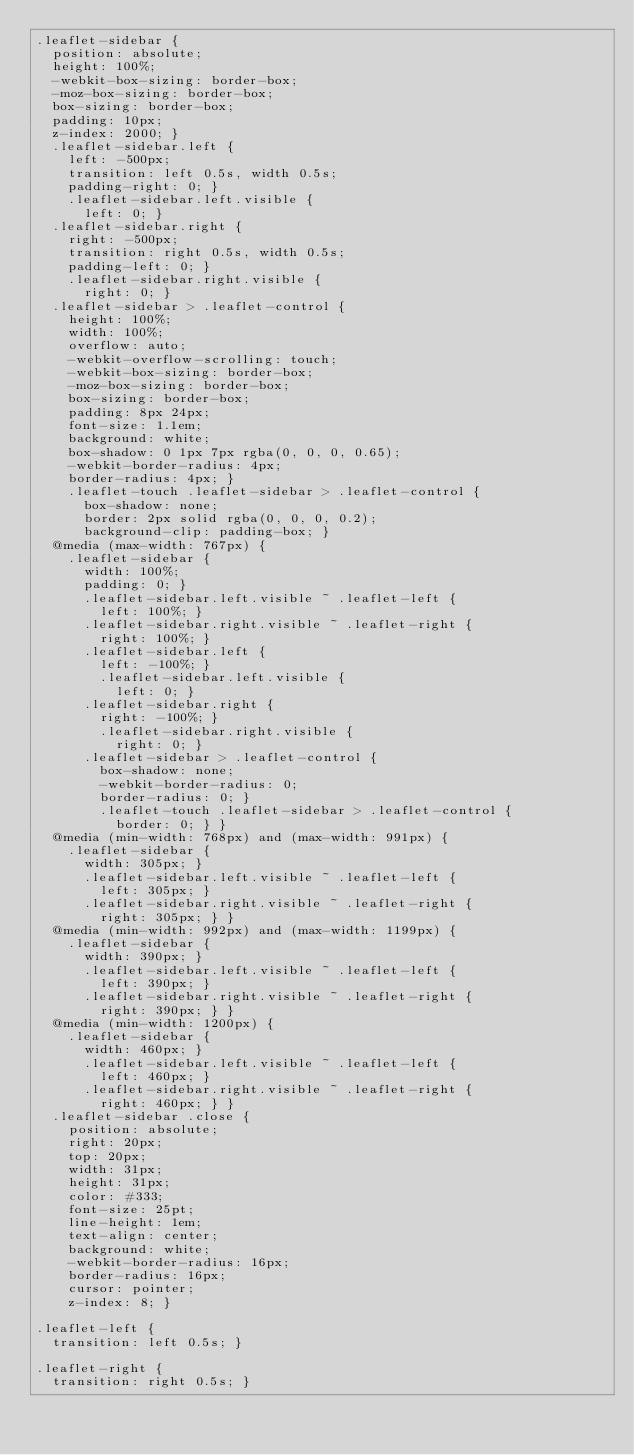Convert code to text. <code><loc_0><loc_0><loc_500><loc_500><_CSS_>.leaflet-sidebar {
  position: absolute;
  height: 100%;
  -webkit-box-sizing: border-box;
  -moz-box-sizing: border-box;
  box-sizing: border-box;
  padding: 10px;
  z-index: 2000; }
  .leaflet-sidebar.left {
    left: -500px;
    transition: left 0.5s, width 0.5s;
    padding-right: 0; }
    .leaflet-sidebar.left.visible {
      left: 0; }
  .leaflet-sidebar.right {
    right: -500px;
    transition: right 0.5s, width 0.5s;
    padding-left: 0; }
    .leaflet-sidebar.right.visible {
      right: 0; }
  .leaflet-sidebar > .leaflet-control {
    height: 100%;
    width: 100%;
    overflow: auto;
    -webkit-overflow-scrolling: touch;
    -webkit-box-sizing: border-box;
    -moz-box-sizing: border-box;
    box-sizing: border-box;
    padding: 8px 24px;
    font-size: 1.1em;
    background: white;
    box-shadow: 0 1px 7px rgba(0, 0, 0, 0.65);
    -webkit-border-radius: 4px;
    border-radius: 4px; }
    .leaflet-touch .leaflet-sidebar > .leaflet-control {
      box-shadow: none;
      border: 2px solid rgba(0, 0, 0, 0.2);
      background-clip: padding-box; }
  @media (max-width: 767px) {
    .leaflet-sidebar {
      width: 100%;
      padding: 0; }
      .leaflet-sidebar.left.visible ~ .leaflet-left {
        left: 100%; }
      .leaflet-sidebar.right.visible ~ .leaflet-right {
        right: 100%; }
      .leaflet-sidebar.left {
        left: -100%; }
        .leaflet-sidebar.left.visible {
          left: 0; }
      .leaflet-sidebar.right {
        right: -100%; }
        .leaflet-sidebar.right.visible {
          right: 0; }
      .leaflet-sidebar > .leaflet-control {
        box-shadow: none;
        -webkit-border-radius: 0;
        border-radius: 0; }
        .leaflet-touch .leaflet-sidebar > .leaflet-control {
          border: 0; } }
  @media (min-width: 768px) and (max-width: 991px) {
    .leaflet-sidebar {
      width: 305px; }
      .leaflet-sidebar.left.visible ~ .leaflet-left {
        left: 305px; }
      .leaflet-sidebar.right.visible ~ .leaflet-right {
        right: 305px; } }
  @media (min-width: 992px) and (max-width: 1199px) {
    .leaflet-sidebar {
      width: 390px; }
      .leaflet-sidebar.left.visible ~ .leaflet-left {
        left: 390px; }
      .leaflet-sidebar.right.visible ~ .leaflet-right {
        right: 390px; } }
  @media (min-width: 1200px) {
    .leaflet-sidebar {
      width: 460px; }
      .leaflet-sidebar.left.visible ~ .leaflet-left {
        left: 460px; }
      .leaflet-sidebar.right.visible ~ .leaflet-right {
        right: 460px; } }
  .leaflet-sidebar .close {
    position: absolute;
    right: 20px;
    top: 20px;
    width: 31px;
    height: 31px;
    color: #333;
    font-size: 25pt;
    line-height: 1em;
    text-align: center;
    background: white;
    -webkit-border-radius: 16px;
    border-radius: 16px;
    cursor: pointer;
    z-index: 8; }

.leaflet-left {
  transition: left 0.5s; }

.leaflet-right {
  transition: right 0.5s; }
</code> 